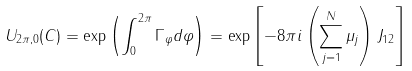<formula> <loc_0><loc_0><loc_500><loc_500>U _ { 2 \pi , 0 } ( C ) = \exp \left ( \int ^ { 2 \pi } _ { 0 } \Gamma _ { \varphi } d \varphi \right ) = \exp \left [ - 8 \pi i \left ( \sum ^ { N } _ { j = 1 } \mu _ { j } \right ) J _ { 1 2 } \right ]</formula> 